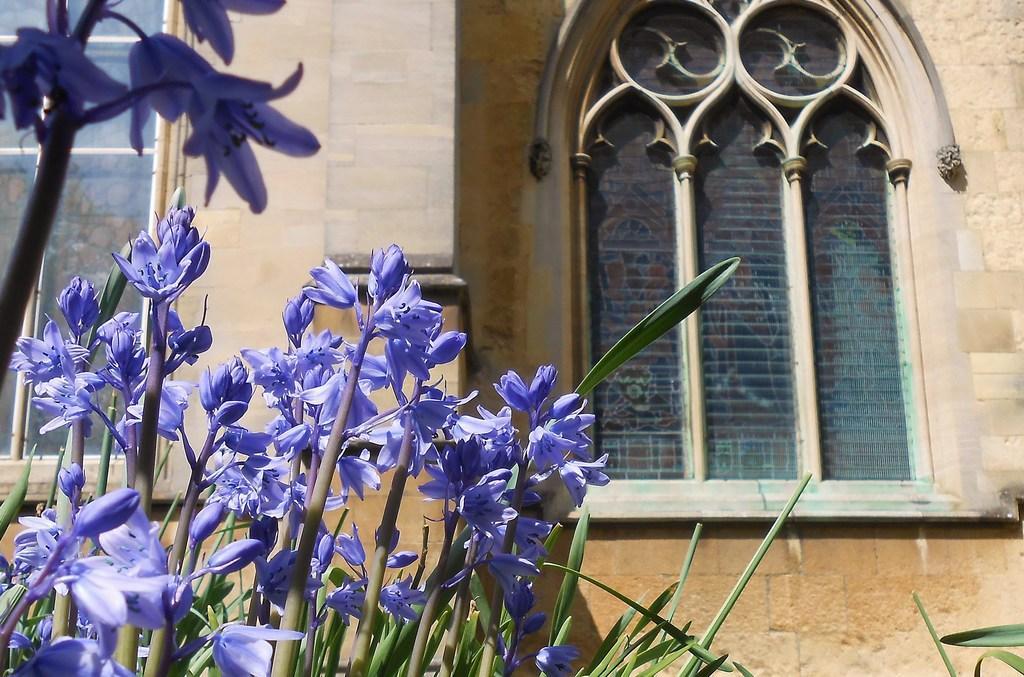Please provide a concise description of this image. In the center of the image we can see building, windows, wall. At the bottom of the image we can see plants, flowers, leaves. 